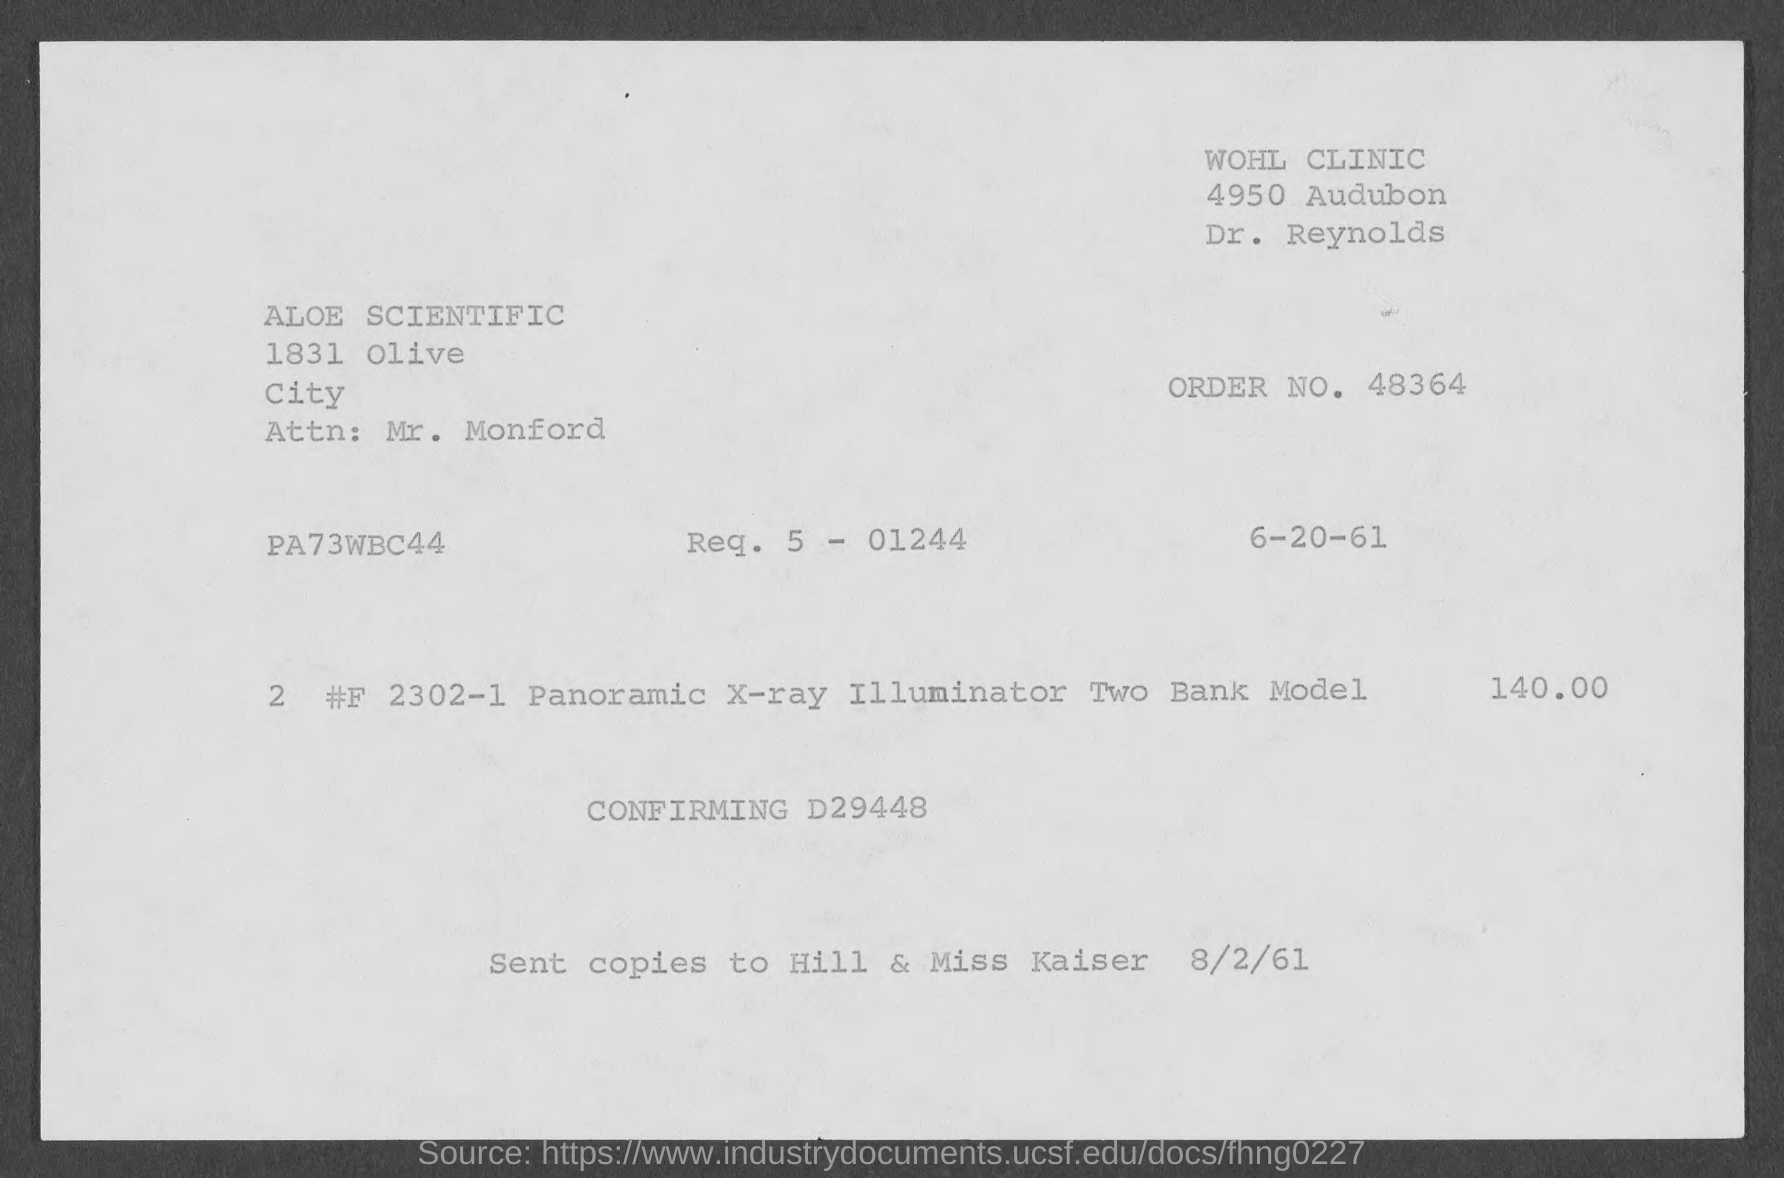Give some essential details in this illustration. The amount mentioned in the given form is 140.00.. The order number mentioned on the given page is 48364... The date mentioned in the given page is June 20, 1961. The given page mentions a city named Olive City. 